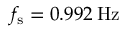Convert formula to latex. <formula><loc_0><loc_0><loc_500><loc_500>f _ { s } = 0 . 9 9 2 \, H z</formula> 